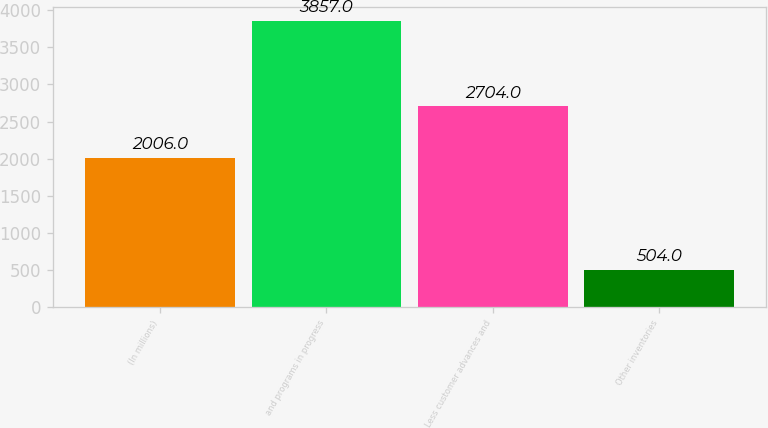<chart> <loc_0><loc_0><loc_500><loc_500><bar_chart><fcel>(In millions)<fcel>and programs in progress<fcel>Less customer advances and<fcel>Other inventories<nl><fcel>2006<fcel>3857<fcel>2704<fcel>504<nl></chart> 